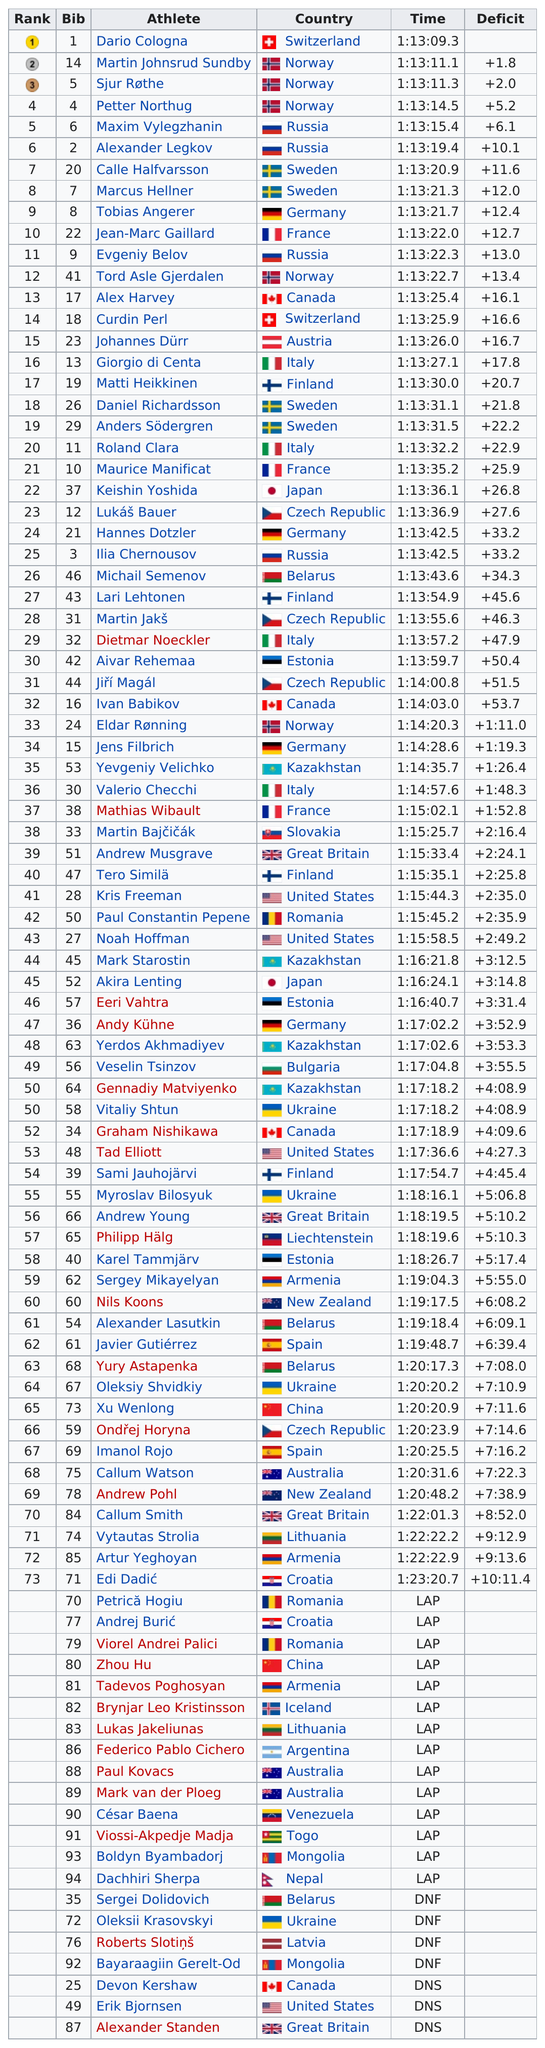Outline some significant characteristics in this image. Thirty-three competitors did not participate in the race at all. Marcus Hellner and Calle Halfvarsson are both from Sweden. The total number of athletes who competed was 94. Maxim Vylegzhanin is the athlete who came in after Petter Northug in a competition. The total number of athletes from Norway is 5. 